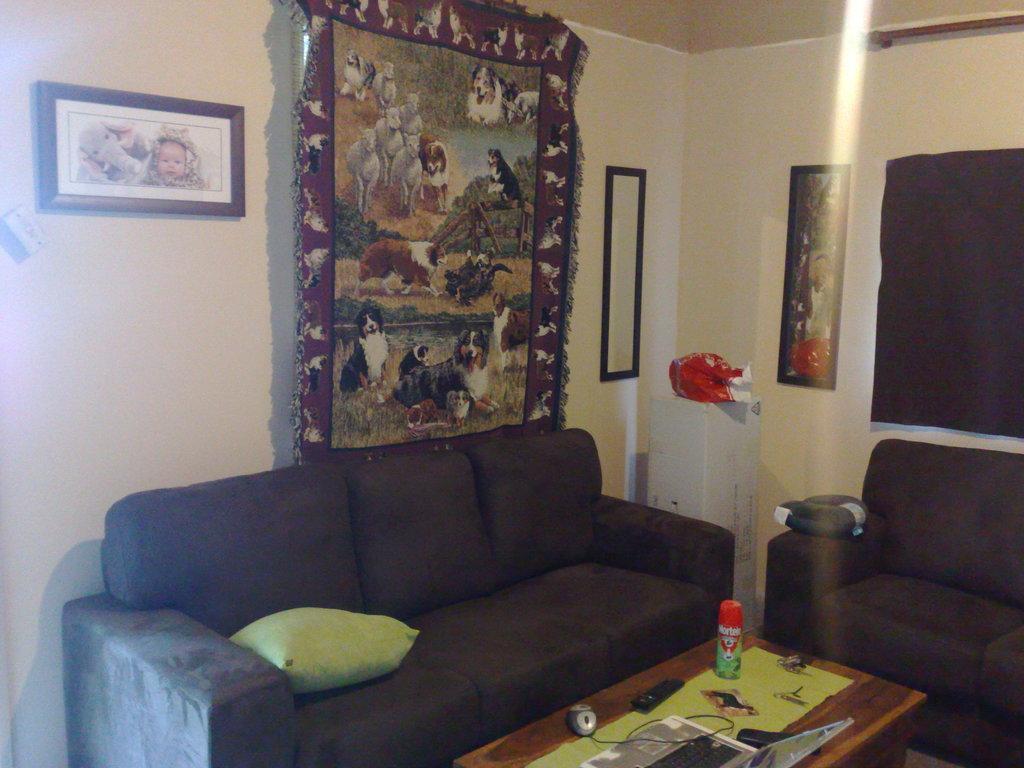Please provide a concise description of this image. It is a room inside the house , there are two sofas which are of black color and there is a table placed in front of a big sofa, there is a laptop and mouse on the table and also a bottle beside this sofa there is a white color pillar beside this to the wall there is a photo poster, behind the big sofa there is a dog's poster and to the left side of it there is another photo frame in the background there is a wall, a white color cloth. 